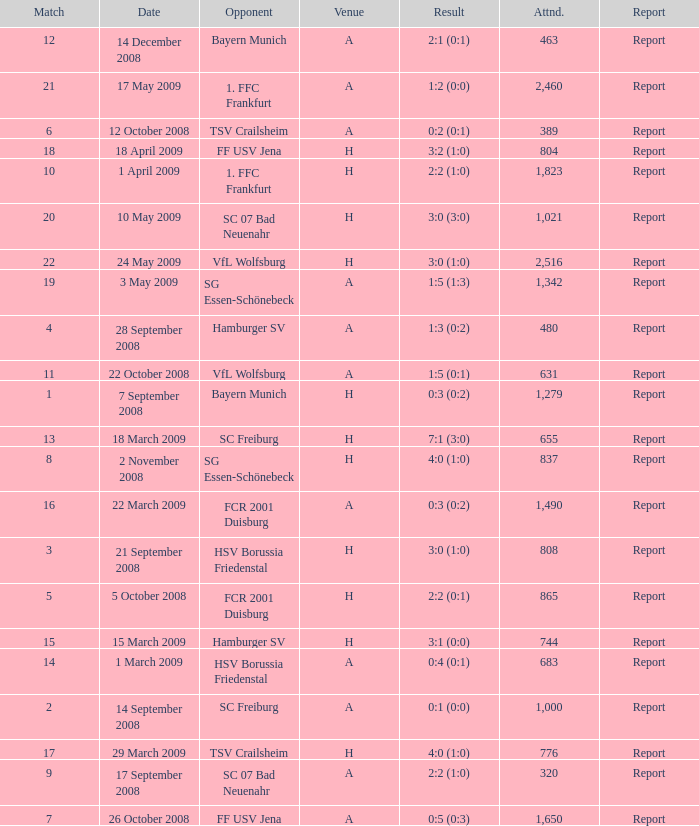Can you parse all the data within this table? {'header': ['Match', 'Date', 'Opponent', 'Venue', 'Result', 'Attnd.', 'Report'], 'rows': [['12', '14 December 2008', 'Bayern Munich', 'A', '2:1 (0:1)', '463', 'Report'], ['21', '17 May 2009', '1. FFC Frankfurt', 'A', '1:2 (0:0)', '2,460', 'Report'], ['6', '12 October 2008', 'TSV Crailsheim', 'A', '0:2 (0:1)', '389', 'Report'], ['18', '18 April 2009', 'FF USV Jena', 'H', '3:2 (1:0)', '804', 'Report'], ['10', '1 April 2009', '1. FFC Frankfurt', 'H', '2:2 (1:0)', '1,823', 'Report'], ['20', '10 May 2009', 'SC 07 Bad Neuenahr', 'H', '3:0 (3:0)', '1,021', 'Report'], ['22', '24 May 2009', 'VfL Wolfsburg', 'H', '3:0 (1:0)', '2,516', 'Report'], ['19', '3 May 2009', 'SG Essen-Schönebeck', 'A', '1:5 (1:3)', '1,342', 'Report'], ['4', '28 September 2008', 'Hamburger SV', 'A', '1:3 (0:2)', '480', 'Report'], ['11', '22 October 2008', 'VfL Wolfsburg', 'A', '1:5 (0:1)', '631', 'Report'], ['1', '7 September 2008', 'Bayern Munich', 'H', '0:3 (0:2)', '1,279', 'Report'], ['13', '18 March 2009', 'SC Freiburg', 'H', '7:1 (3:0)', '655', 'Report'], ['8', '2 November 2008', 'SG Essen-Schönebeck', 'H', '4:0 (1:0)', '837', 'Report'], ['16', '22 March 2009', 'FCR 2001 Duisburg', 'A', '0:3 (0:2)', '1,490', 'Report'], ['3', '21 September 2008', 'HSV Borussia Friedenstal', 'H', '3:0 (1:0)', '808', 'Report'], ['5', '5 October 2008', 'FCR 2001 Duisburg', 'H', '2:2 (0:1)', '865', 'Report'], ['15', '15 March 2009', 'Hamburger SV', 'H', '3:1 (0:0)', '744', 'Report'], ['14', '1 March 2009', 'HSV Borussia Friedenstal', 'A', '0:4 (0:1)', '683', 'Report'], ['2', '14 September 2008', 'SC Freiburg', 'A', '0:1 (0:0)', '1,000', 'Report'], ['17', '29 March 2009', 'TSV Crailsheim', 'H', '4:0 (1:0)', '776', 'Report'], ['9', '17 September 2008', 'SC 07 Bad Neuenahr', 'A', '2:2 (1:0)', '320', 'Report'], ['7', '26 October 2008', 'FF USV Jena', 'A', '0:5 (0:3)', '1,650', 'Report']]} Which match did FCR 2001 Duisburg participate as the opponent? 21.0. 